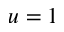<formula> <loc_0><loc_0><loc_500><loc_500>u = 1</formula> 